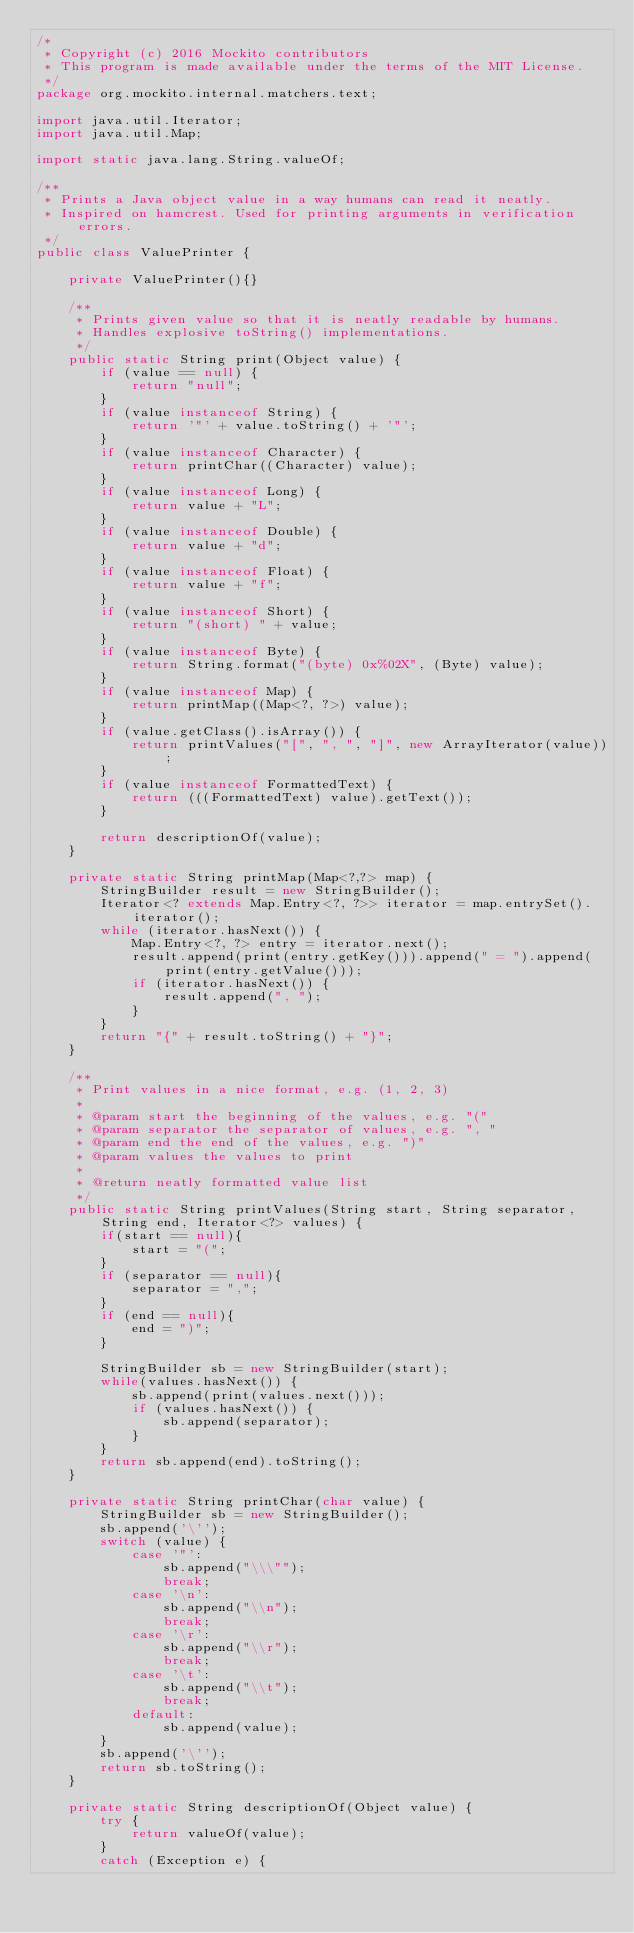<code> <loc_0><loc_0><loc_500><loc_500><_Java_>/*
 * Copyright (c) 2016 Mockito contributors
 * This program is made available under the terms of the MIT License.
 */
package org.mockito.internal.matchers.text;

import java.util.Iterator;
import java.util.Map;

import static java.lang.String.valueOf;

/**
 * Prints a Java object value in a way humans can read it neatly.
 * Inspired on hamcrest. Used for printing arguments in verification errors.
 */
public class ValuePrinter {

    private ValuePrinter(){}

    /**
     * Prints given value so that it is neatly readable by humans.
     * Handles explosive toString() implementations.
     */
    public static String print(Object value) {
        if (value == null) {
            return "null";
        }
        if (value instanceof String) {
            return '"' + value.toString() + '"';
        }
        if (value instanceof Character) {
            return printChar((Character) value);
        }
        if (value instanceof Long) {
            return value + "L";
        }
        if (value instanceof Double) {
            return value + "d";
        }
        if (value instanceof Float) {
            return value + "f";
        }
        if (value instanceof Short) {
            return "(short) " + value;
        }
        if (value instanceof Byte) {
            return String.format("(byte) 0x%02X", (Byte) value);
        }
        if (value instanceof Map) {
            return printMap((Map<?, ?>) value);
        }
        if (value.getClass().isArray()) {
            return printValues("[", ", ", "]", new ArrayIterator(value));
        }
        if (value instanceof FormattedText) {
            return (((FormattedText) value).getText());
        }

        return descriptionOf(value);
    }

    private static String printMap(Map<?,?> map) {
        StringBuilder result = new StringBuilder();
        Iterator<? extends Map.Entry<?, ?>> iterator = map.entrySet().iterator();
        while (iterator.hasNext()) {
            Map.Entry<?, ?> entry = iterator.next();
            result.append(print(entry.getKey())).append(" = ").append(print(entry.getValue()));
            if (iterator.hasNext()) {
                result.append(", ");
            }
        }
        return "{" + result.toString() + "}";
    }

    /**
     * Print values in a nice format, e.g. (1, 2, 3)
     *
     * @param start the beginning of the values, e.g. "("
     * @param separator the separator of values, e.g. ", "
     * @param end the end of the values, e.g. ")"
     * @param values the values to print
     *
     * @return neatly formatted value list
     */
    public static String printValues(String start, String separator, String end, Iterator<?> values) {
        if(start == null){
            start = "(";
        }
        if (separator == null){
            separator = ",";
        }
        if (end == null){
            end = ")";
        }

        StringBuilder sb = new StringBuilder(start);
        while(values.hasNext()) {
            sb.append(print(values.next()));
            if (values.hasNext()) {
                sb.append(separator);
            }
        }
        return sb.append(end).toString();
    }

    private static String printChar(char value) {
        StringBuilder sb = new StringBuilder();
        sb.append('\'');
        switch (value) {
            case '"':
                sb.append("\\\"");
                break;
            case '\n':
                sb.append("\\n");
                break;
            case '\r':
                sb.append("\\r");
                break;
            case '\t':
                sb.append("\\t");
                break;
            default:
                sb.append(value);
        }
        sb.append('\'');
        return sb.toString();
    }

    private static String descriptionOf(Object value) {
        try {
            return valueOf(value);
        }
        catch (Exception e) {</code> 